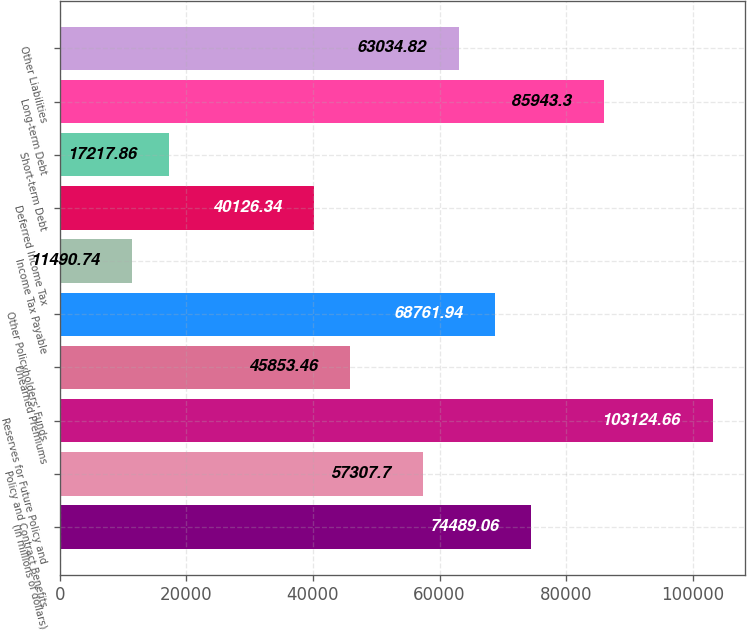Convert chart to OTSL. <chart><loc_0><loc_0><loc_500><loc_500><bar_chart><fcel>(in millions of dollars)<fcel>Policy and Contract Benefits<fcel>Reserves for Future Policy and<fcel>Unearned Premiums<fcel>Other Policyholders' Funds<fcel>Income Tax Payable<fcel>Deferred Income Tax<fcel>Short-term Debt<fcel>Long-term Debt<fcel>Other Liabilities<nl><fcel>74489.1<fcel>57307.7<fcel>103125<fcel>45853.5<fcel>68761.9<fcel>11490.7<fcel>40126.3<fcel>17217.9<fcel>85943.3<fcel>63034.8<nl></chart> 